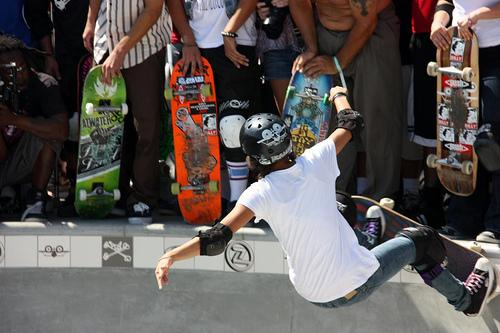Where did OG skateboarders develop this style of boarding? Please explain your reasoning. swimming pools. In california many people have these in their backyard and empty ones are deep enough to practice skating tricks. 